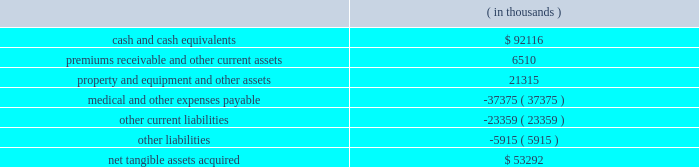Humana inc .
Notes to consolidated financial statements 2014 ( continued ) the grant-date fair value of the award will be estimated using option-pricing models .
In addition , certain tax effects of stock option exercises will be reported as a financing activity rather than an operating activity in the statements of cash flows .
We adopted sfas 123r on january 1 , 2006 under the retrospective transition method using the black-scholes pricing model .
The effect of expensing stock options under a fair value approach using the black-scholes pricing model on diluted earnings per common share for the years ended december 31 , 2005 , 2004 and 2003 is disclosed on page 69 .
In addition , the classification of cash inflows from any excess tax benefit associated with exercising stock options will change from an operating activity to a financing activity in the consolidated statements of cash flows with no impact on total cash flows .
We estimate the impact of this change in classification will decrease operating cash flows ( and increase financing cash flows ) by approximately $ 15.5 million in 2005 , $ 3.7 million in 2004 , and $ 15.2 million in 2003 .
Stock option expense after adopting sfas 123r is not expected to be materially different than our pro forma disclosure on page 69 and is dependent on levels of stock options granted during 2006 .
Acquisitions in january 2006 , our commercial segment reached an agreement to acquire cha service company , or cha health , a health plan serving employer groups in kentucky , for cash consideration of approximately $ 60.0 million plus any excess statutory surplus .
This transaction , which is subject to regulatory approval , is expected to close effective in the second quarter of 2006 .
On december 20 , 2005 , our commercial segment acquired corphealth , inc. , or corphealth , a behavioral health care management company , for cash consideration of approximately $ 54.2 million , including transaction costs .
This acquisition allows humana to integrate coverage of medical and behavior health benefits .
Net tangible assets acquired of $ 6.0 million primarily consisted of cash and cash equivalents .
The purchase price exceeded the estimated fair value of the net tangible assets acquired by approximately $ 48.2 million .
We preliminarily allocated this excess purchase price to other intangible assets of $ 8.6 million and associated deferred tax liabilities of $ 3.2 million , and non-deductible goodwill of $ 42.8 million .
The other intangible assets , which consist primarily of customer contracts , have a weighted average useful life of 14.7 years .
The allocation is subject to change pending completion of the valuation by a third party valuation specialist firm assisting us in evaluating the fair value of the assets acquired .
On february 16 , 2005 , our government segment acquired careplus health plans of florida , or careplus , as well as its affiliated 10 medical centers and pharmacy company .
Careplus provides medicare advantage hmo plans and benefits to medicare advantage members in miami-dade , broward and palm beach counties .
This acquisition enhances our medicare market position in south florida .
We paid approximately $ 444.9 million in cash , including transaction costs .
We financed the transaction with $ 294.0 million of borrowings under our credit agreement and $ 150.9 million of cash on hand .
The purchase price is subject to a balance sheet settlement process with a nine month claims run-out period .
This settlement , which will be reflected as an adjustment to goodwill , is not expected to be material .
The fair value of the acquired tangible assets ( assumed liabilities ) consisted of the following: .

What is the total value of liabilities , in thousands? 
Rationale: it is the sum of all liabilities.\\n
Computations: ((37375 + 23359) + 5915)
Answer: 66649.0. 